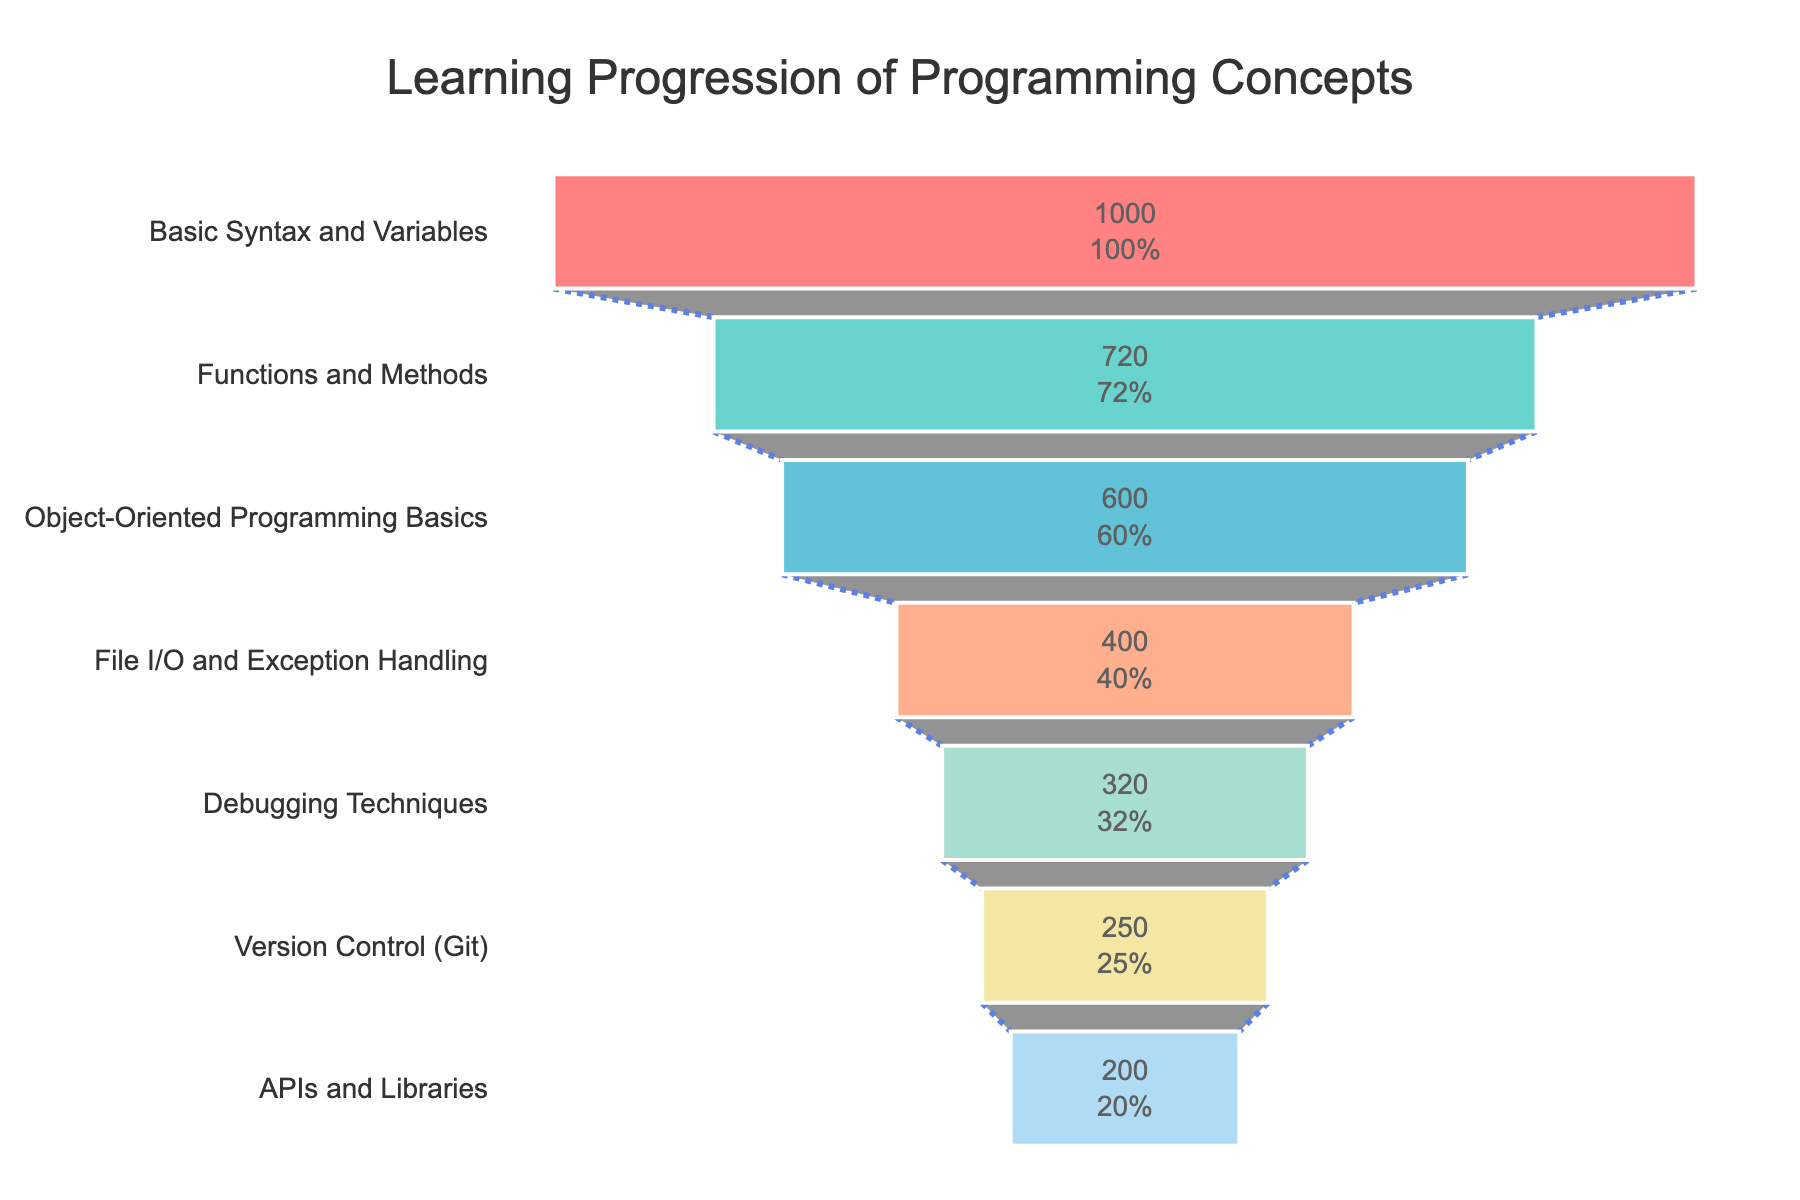How many learners are there at the "Basic Syntax and Variables" stage? The funnel chart shows the number of learners at each stage of learning progression. "Basic Syntax and Variables" is listed at the top with 1000 learners.
Answer: 1000 What percentage of initial learners is lost by the time they reach "File I/O and Exception Handling"? The funnel chart displays both the number of learners and the percent of initial learners at each stage. "File I/O and Exception Handling" has 400 learners out of the initial 1000, which is 40% of the initial learners. Hence, the percentage lost is 100% - 40% = 60%.
Answer: 60% Which stage has the least number of learners? By examining the bottom of the funnel chart, the stage "APIs and Libraries" has the smallest funnel section, indicating it has the least number of learners, which is 200.
Answer: APIs and Libraries What is the difference in the number of learners between "Object-Oriented Programming Basics" and "Version Control (Git)"? According to the funnel chart, "Object-Oriented Programming Basics" has 600 learners, and "Version Control (Git)" has 250 learners. The difference is 600 - 250 = 350.
Answer: 350 What is the average number of learners across all stages? Sum of learners at each stage is: 1000+720+600+400+320+250+200 = 3490. There are 7 stages. Therefore, the average is 3490 / 7 ≈ 498.57.
Answer: ~498.57 By what percentage do the learners decrease from "Basic Syntax and Variables" to "Functions and Methods"? The number of learners decreases from 1000 to 720. The percentage decrease is calculated as ((1000 - 720) / 1000) * 100 = 28%.
Answer: 28% 